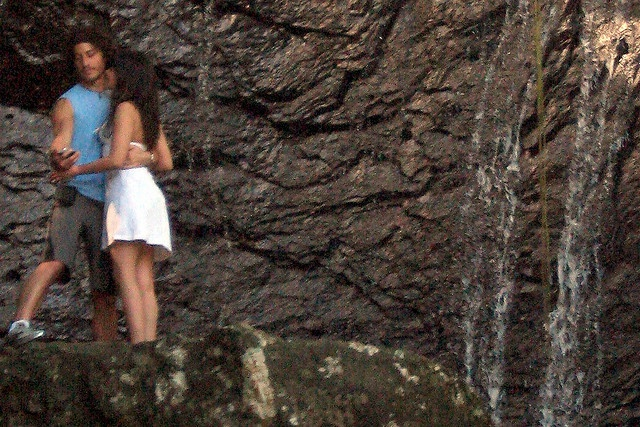Describe the objects in this image and their specific colors. I can see people in black, white, brown, and salmon tones, people in black, gray, maroon, and brown tones, and cell phone in black, gray, and maroon tones in this image. 